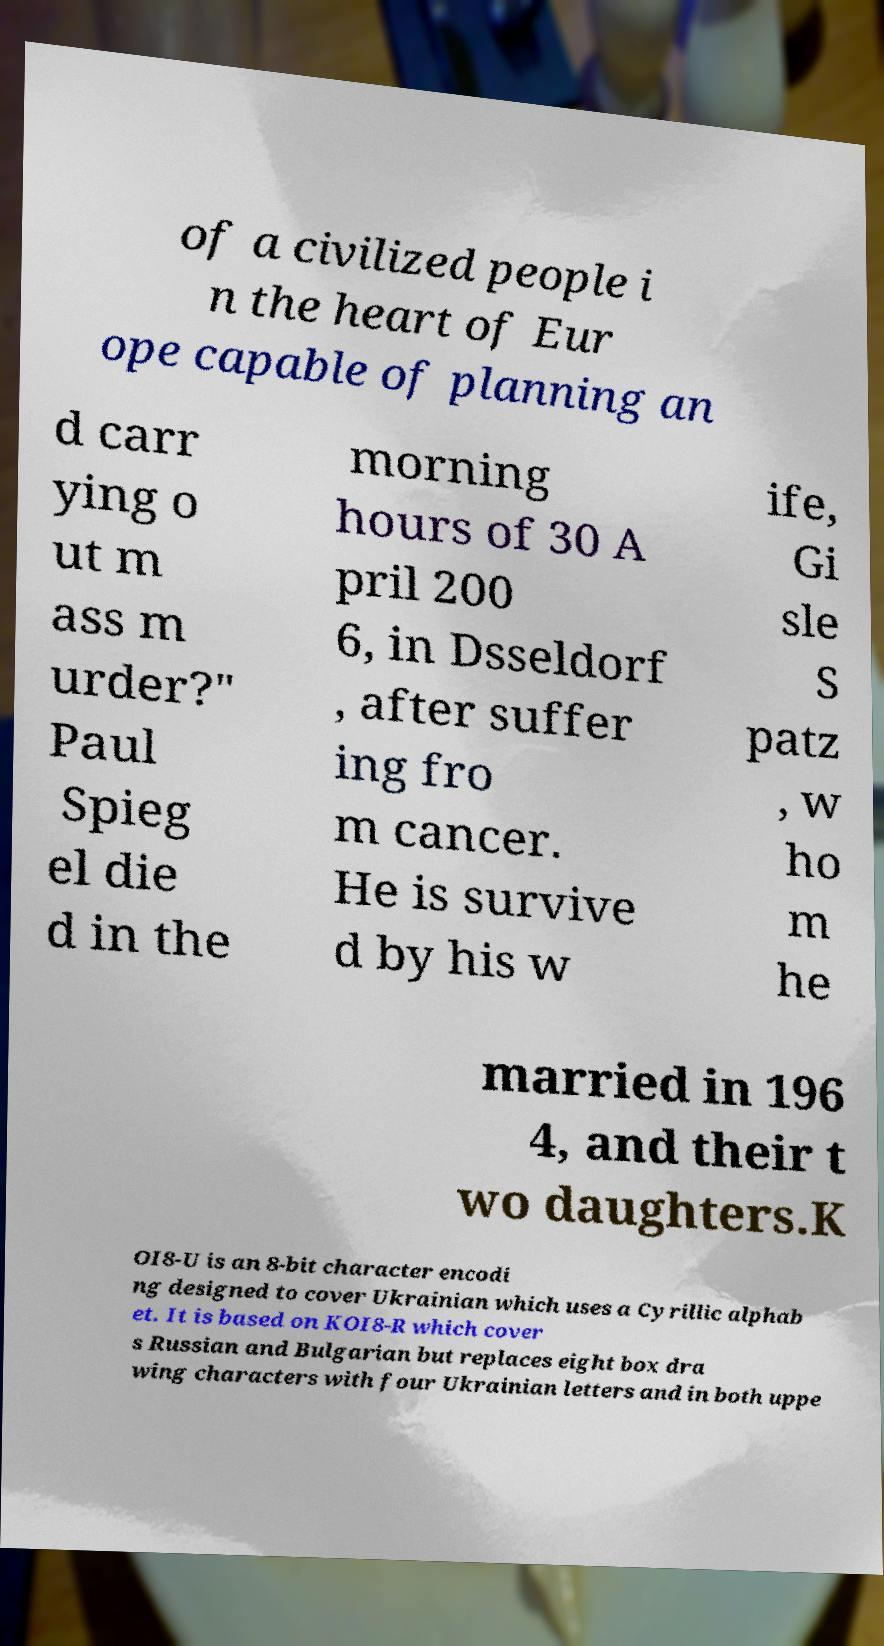For documentation purposes, I need the text within this image transcribed. Could you provide that? of a civilized people i n the heart of Eur ope capable of planning an d carr ying o ut m ass m urder?" Paul Spieg el die d in the morning hours of 30 A pril 200 6, in Dsseldorf , after suffer ing fro m cancer. He is survive d by his w ife, Gi sle S patz , w ho m he married in 196 4, and their t wo daughters.K OI8-U is an 8-bit character encodi ng designed to cover Ukrainian which uses a Cyrillic alphab et. It is based on KOI8-R which cover s Russian and Bulgarian but replaces eight box dra wing characters with four Ukrainian letters and in both uppe 